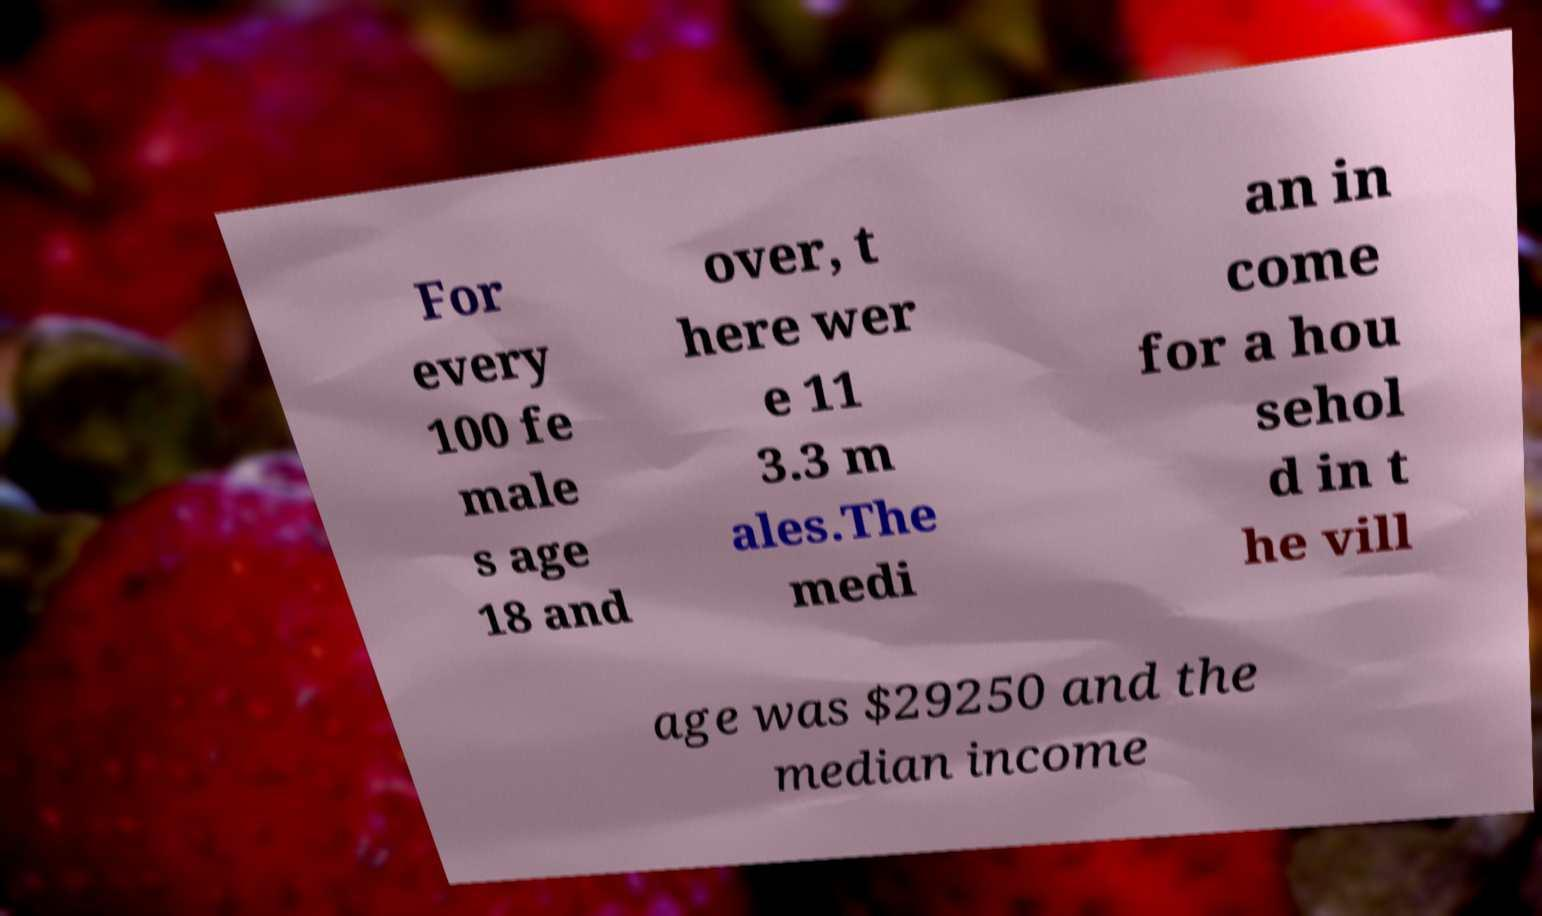Can you read and provide the text displayed in the image?This photo seems to have some interesting text. Can you extract and type it out for me? For every 100 fe male s age 18 and over, t here wer e 11 3.3 m ales.The medi an in come for a hou sehol d in t he vill age was $29250 and the median income 